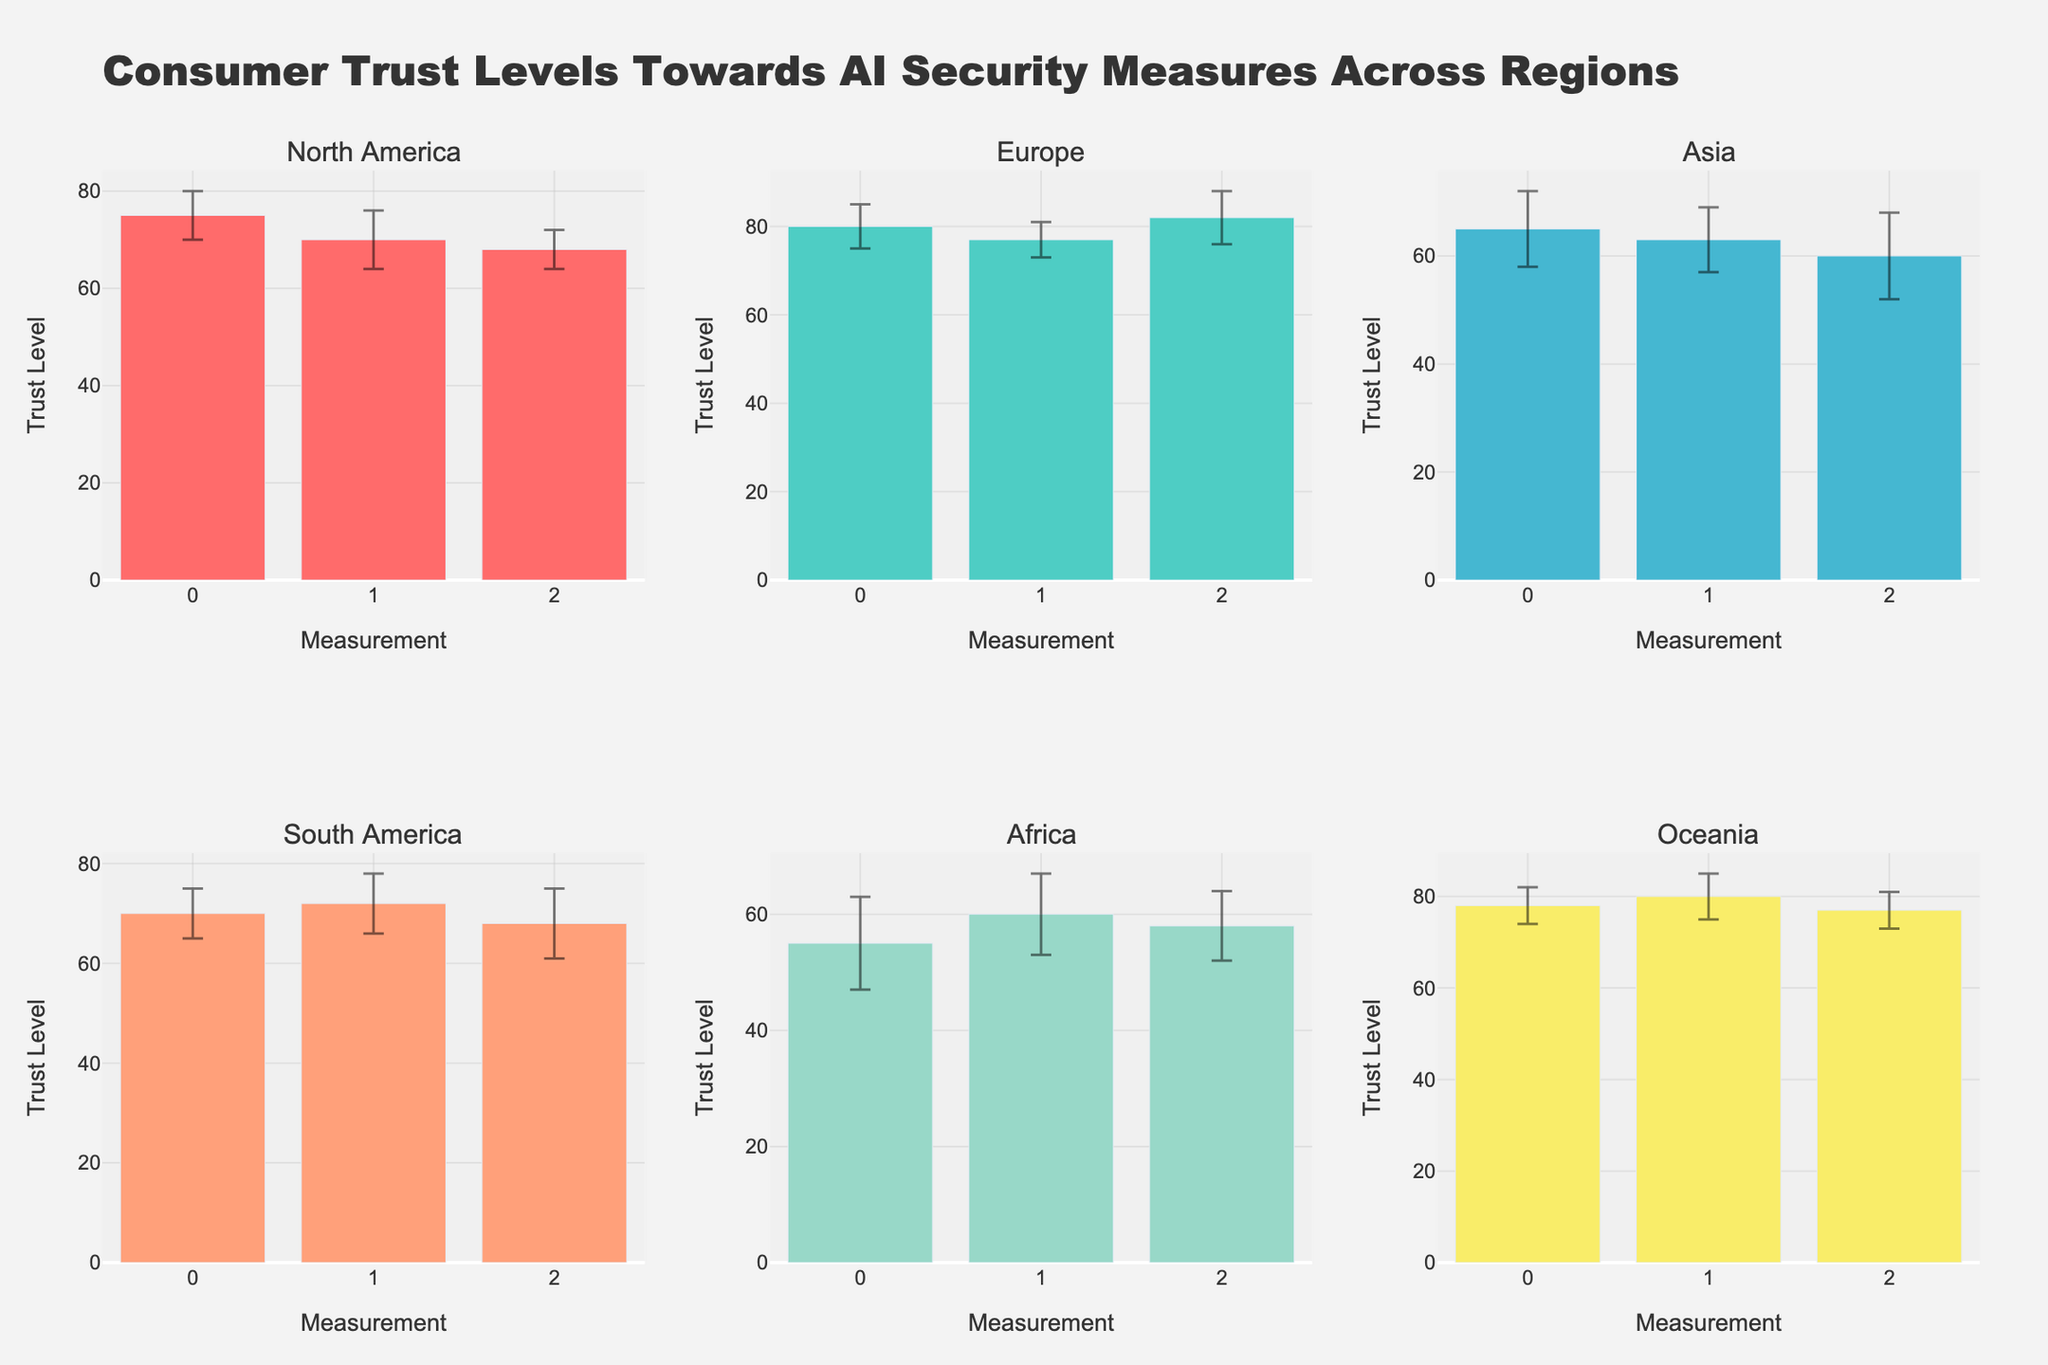How many regions are displayed in the figure? The figure has six subplot titles, each representing a unique region.
Answer: Six What is the overall title of the figure? The main title is usually displayed at the top center of the figure.
Answer: Consumer Trust Levels Towards AI Security Measures Across Regions Which region has the highest maximum trust level? By visually comparing the highest bars across all subplots, Europe stands out with a trust level of 82.
Answer: Europe Which region has the lowest average trust level? To determine this, visually average the height of bars in each subplot. Africa appears to have the lowest average trust level.
Answer: Africa What is the range of trust levels for South America? The bars for South America go from a minimum of 68 to a maximum of 72.
Answer: 68 to 72 Does North America have a wider variance in its trust index deviations compared to Europe? Comparing the error bars, North America shows more spread in its deviations (4 to 6) whereas Europe is (4 to 6) making them similar.
Answer: No Which region has the largest error bar on any single data point? By checking the size of the error bars, Asia has the largest with an 8 deviation.
Answer: Asia In which subplot do we see the most consistent trust levels? Oceania's subplot shows smaller error bars indicating more consistency in trust levels.
Answer: Oceania What are the trust levels in Asia, and how consistent are they? The trust levels in Asia are 60, 63, and 65 with relatively large error bars (up to 8), suggesting inconsistency.
Answer: Trust levels: 60, 63, 65; Inconsistent Which region has the smallest minimum trust level and what is it? By comparing the smallest bar heights, Africa has the minimum trust level of 55.
Answer: Africa, 55 